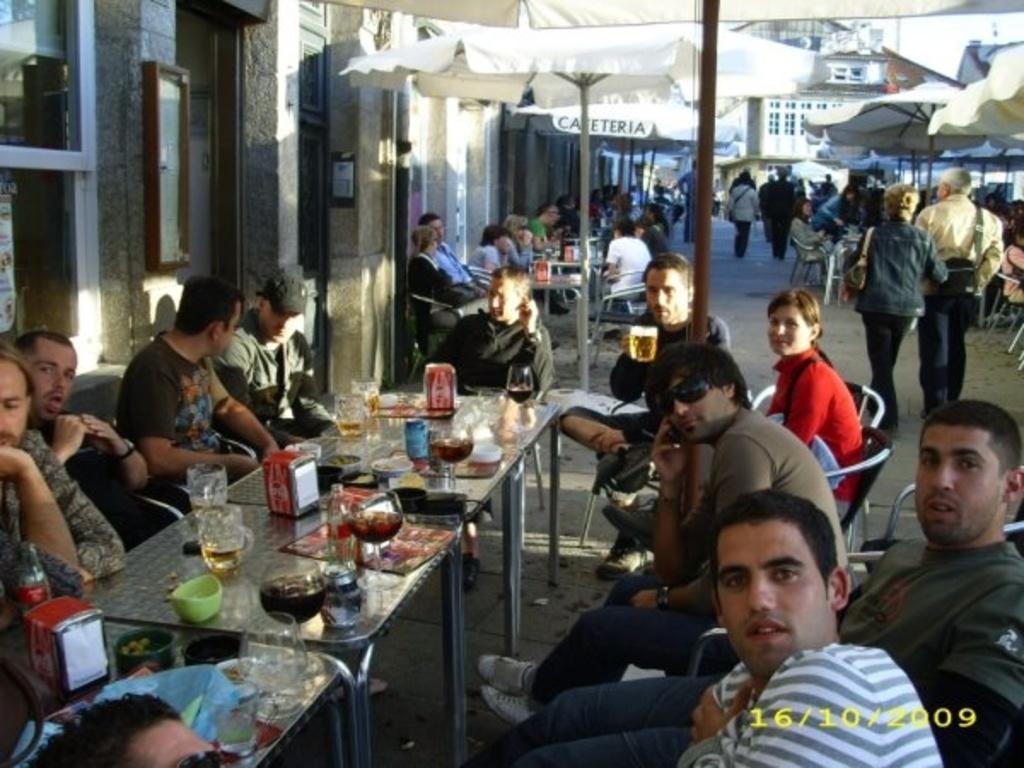How would you summarize this image in a sentence or two? In this picture we can see there are umbrellas with stand and there are groups of people, some people are sitting on chairs and some people are standing. In front of the sitting people, there are tables and on the tables there are glasses, a bottle and some objects. Behind the umbrellas, there are buildings. On the image, there is a watermark. 